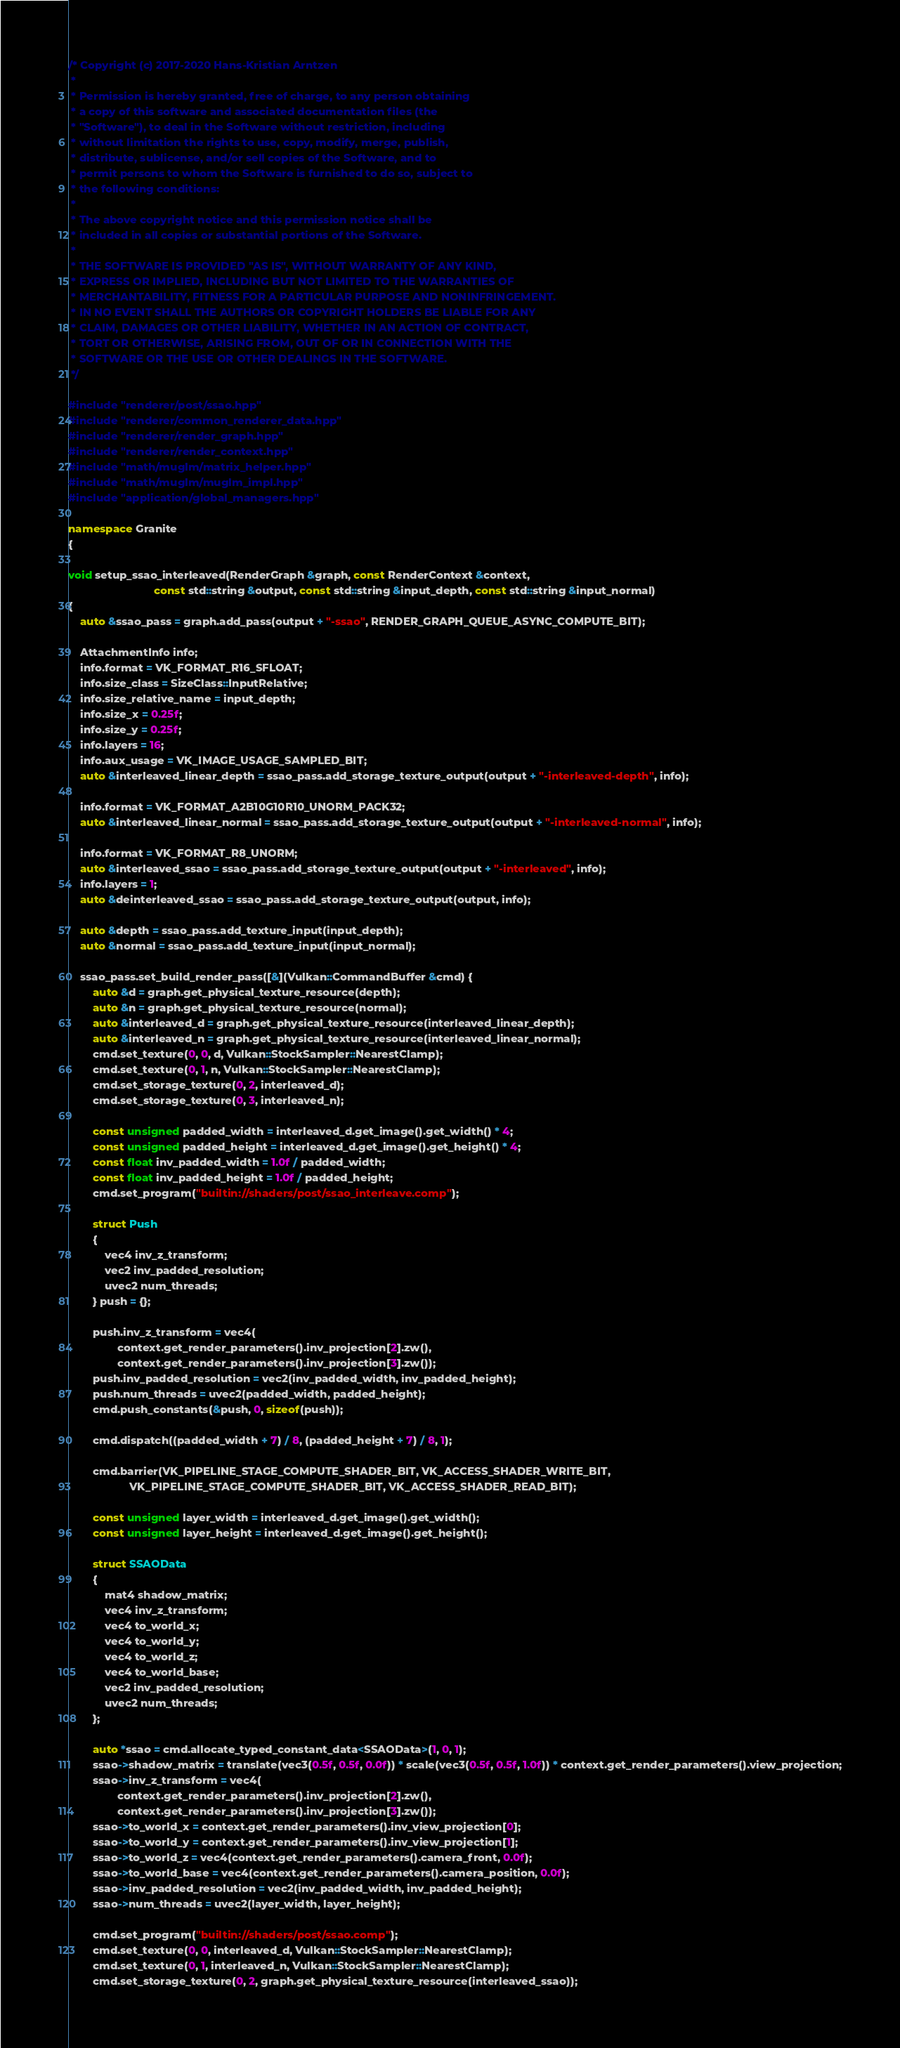<code> <loc_0><loc_0><loc_500><loc_500><_C++_>/* Copyright (c) 2017-2020 Hans-Kristian Arntzen
 *
 * Permission is hereby granted, free of charge, to any person obtaining
 * a copy of this software and associated documentation files (the
 * "Software"), to deal in the Software without restriction, including
 * without limitation the rights to use, copy, modify, merge, publish,
 * distribute, sublicense, and/or sell copies of the Software, and to
 * permit persons to whom the Software is furnished to do so, subject to
 * the following conditions:
 *
 * The above copyright notice and this permission notice shall be
 * included in all copies or substantial portions of the Software.
 *
 * THE SOFTWARE IS PROVIDED "AS IS", WITHOUT WARRANTY OF ANY KIND,
 * EXPRESS OR IMPLIED, INCLUDING BUT NOT LIMITED TO THE WARRANTIES OF
 * MERCHANTABILITY, FITNESS FOR A PARTICULAR PURPOSE AND NONINFRINGEMENT.
 * IN NO EVENT SHALL THE AUTHORS OR COPYRIGHT HOLDERS BE LIABLE FOR ANY
 * CLAIM, DAMAGES OR OTHER LIABILITY, WHETHER IN AN ACTION OF CONTRACT,
 * TORT OR OTHERWISE, ARISING FROM, OUT OF OR IN CONNECTION WITH THE
 * SOFTWARE OR THE USE OR OTHER DEALINGS IN THE SOFTWARE.
 */

#include "renderer/post/ssao.hpp"
#include "renderer/common_renderer_data.hpp"
#include "renderer/render_graph.hpp"
#include "renderer/render_context.hpp"
#include "math/muglm/matrix_helper.hpp"
#include "math/muglm/muglm_impl.hpp"
#include "application/global_managers.hpp"

namespace Granite
{

void setup_ssao_interleaved(RenderGraph &graph, const RenderContext &context,
                            const std::string &output, const std::string &input_depth, const std::string &input_normal)
{
	auto &ssao_pass = graph.add_pass(output + "-ssao", RENDER_GRAPH_QUEUE_ASYNC_COMPUTE_BIT);

	AttachmentInfo info;
	info.format = VK_FORMAT_R16_SFLOAT;
	info.size_class = SizeClass::InputRelative;
	info.size_relative_name = input_depth;
	info.size_x = 0.25f;
	info.size_y = 0.25f;
	info.layers = 16;
	info.aux_usage = VK_IMAGE_USAGE_SAMPLED_BIT;
	auto &interleaved_linear_depth = ssao_pass.add_storage_texture_output(output + "-interleaved-depth", info);

	info.format = VK_FORMAT_A2B10G10R10_UNORM_PACK32;
	auto &interleaved_linear_normal = ssao_pass.add_storage_texture_output(output + "-interleaved-normal", info);

	info.format = VK_FORMAT_R8_UNORM;
	auto &interleaved_ssao = ssao_pass.add_storage_texture_output(output + "-interleaved", info);
	info.layers = 1;
	auto &deinterleaved_ssao = ssao_pass.add_storage_texture_output(output, info);

	auto &depth = ssao_pass.add_texture_input(input_depth);
	auto &normal = ssao_pass.add_texture_input(input_normal);

	ssao_pass.set_build_render_pass([&](Vulkan::CommandBuffer &cmd) {
		auto &d = graph.get_physical_texture_resource(depth);
		auto &n = graph.get_physical_texture_resource(normal);
		auto &interleaved_d = graph.get_physical_texture_resource(interleaved_linear_depth);
		auto &interleaved_n = graph.get_physical_texture_resource(interleaved_linear_normal);
		cmd.set_texture(0, 0, d, Vulkan::StockSampler::NearestClamp);
		cmd.set_texture(0, 1, n, Vulkan::StockSampler::NearestClamp);
		cmd.set_storage_texture(0, 2, interleaved_d);
		cmd.set_storage_texture(0, 3, interleaved_n);

		const unsigned padded_width = interleaved_d.get_image().get_width() * 4;
		const unsigned padded_height = interleaved_d.get_image().get_height() * 4;
		const float inv_padded_width = 1.0f / padded_width;
		const float inv_padded_height = 1.0f / padded_height;
		cmd.set_program("builtin://shaders/post/ssao_interleave.comp");

		struct Push
		{
			vec4 inv_z_transform;
			vec2 inv_padded_resolution;
			uvec2 num_threads;
		} push = {};

		push.inv_z_transform = vec4(
				context.get_render_parameters().inv_projection[2].zw(),
				context.get_render_parameters().inv_projection[3].zw());
		push.inv_padded_resolution = vec2(inv_padded_width, inv_padded_height);
		push.num_threads = uvec2(padded_width, padded_height);
		cmd.push_constants(&push, 0, sizeof(push));

		cmd.dispatch((padded_width + 7) / 8, (padded_height + 7) / 8, 1);

		cmd.barrier(VK_PIPELINE_STAGE_COMPUTE_SHADER_BIT, VK_ACCESS_SHADER_WRITE_BIT,
		            VK_PIPELINE_STAGE_COMPUTE_SHADER_BIT, VK_ACCESS_SHADER_READ_BIT);

		const unsigned layer_width = interleaved_d.get_image().get_width();
		const unsigned layer_height = interleaved_d.get_image().get_height();

		struct SSAOData
		{
			mat4 shadow_matrix;
			vec4 inv_z_transform;
			vec4 to_world_x;
			vec4 to_world_y;
			vec4 to_world_z;
			vec4 to_world_base;
			vec2 inv_padded_resolution;
			uvec2 num_threads;
		};

		auto *ssao = cmd.allocate_typed_constant_data<SSAOData>(1, 0, 1);
		ssao->shadow_matrix = translate(vec3(0.5f, 0.5f, 0.0f)) * scale(vec3(0.5f, 0.5f, 1.0f)) * context.get_render_parameters().view_projection;
		ssao->inv_z_transform = vec4(
				context.get_render_parameters().inv_projection[2].zw(),
				context.get_render_parameters().inv_projection[3].zw());
		ssao->to_world_x = context.get_render_parameters().inv_view_projection[0];
		ssao->to_world_y = context.get_render_parameters().inv_view_projection[1];
		ssao->to_world_z = vec4(context.get_render_parameters().camera_front, 0.0f);
		ssao->to_world_base = vec4(context.get_render_parameters().camera_position, 0.0f);
		ssao->inv_padded_resolution = vec2(inv_padded_width, inv_padded_height);
		ssao->num_threads = uvec2(layer_width, layer_height);

		cmd.set_program("builtin://shaders/post/ssao.comp");
		cmd.set_texture(0, 0, interleaved_d, Vulkan::StockSampler::NearestClamp);
		cmd.set_texture(0, 1, interleaved_n, Vulkan::StockSampler::NearestClamp);
		cmd.set_storage_texture(0, 2, graph.get_physical_texture_resource(interleaved_ssao));</code> 